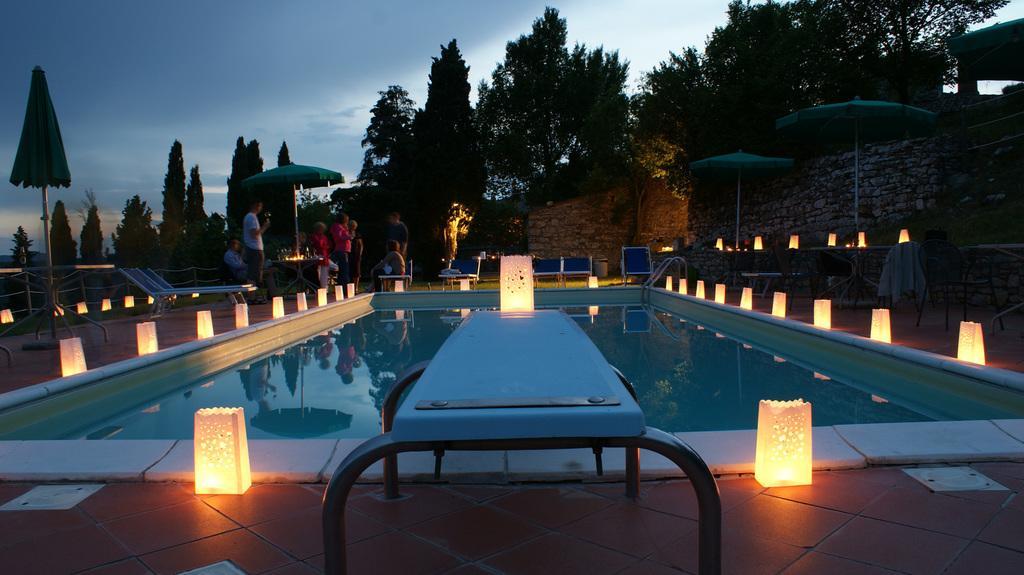Could you give a brief overview of what you see in this image? In this picture we can see a swimming pool decorated with lights around it. In the background, we can see people and trees. 